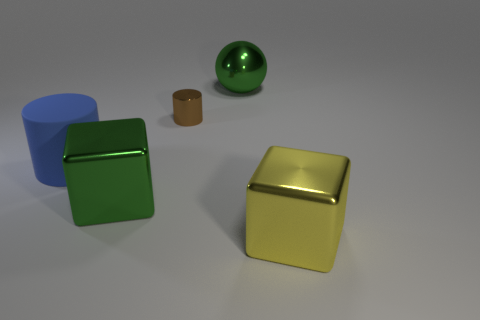Is there anything else that is the same size as the brown shiny cylinder?
Give a very brief answer. No. Are there any other things that are made of the same material as the big blue cylinder?
Your answer should be compact. No. There is a block that is on the right side of the big green object to the right of the big green object in front of the tiny cylinder; how big is it?
Your answer should be compact. Large. Are any blue cylinders visible?
Your answer should be very brief. Yes. What number of big things are the same color as the large sphere?
Ensure brevity in your answer.  1. What number of things are large metallic objects that are behind the big blue object or objects that are to the right of the big blue matte cylinder?
Your answer should be very brief. 4. There is a large metallic thing to the right of the metallic ball; what number of large yellow cubes are to the left of it?
Make the answer very short. 0. What color is the small cylinder that is made of the same material as the green sphere?
Your response must be concise. Brown. Is there a yellow object of the same size as the blue thing?
Your answer should be compact. Yes. There is a yellow shiny object that is the same size as the matte thing; what shape is it?
Your response must be concise. Cube. 